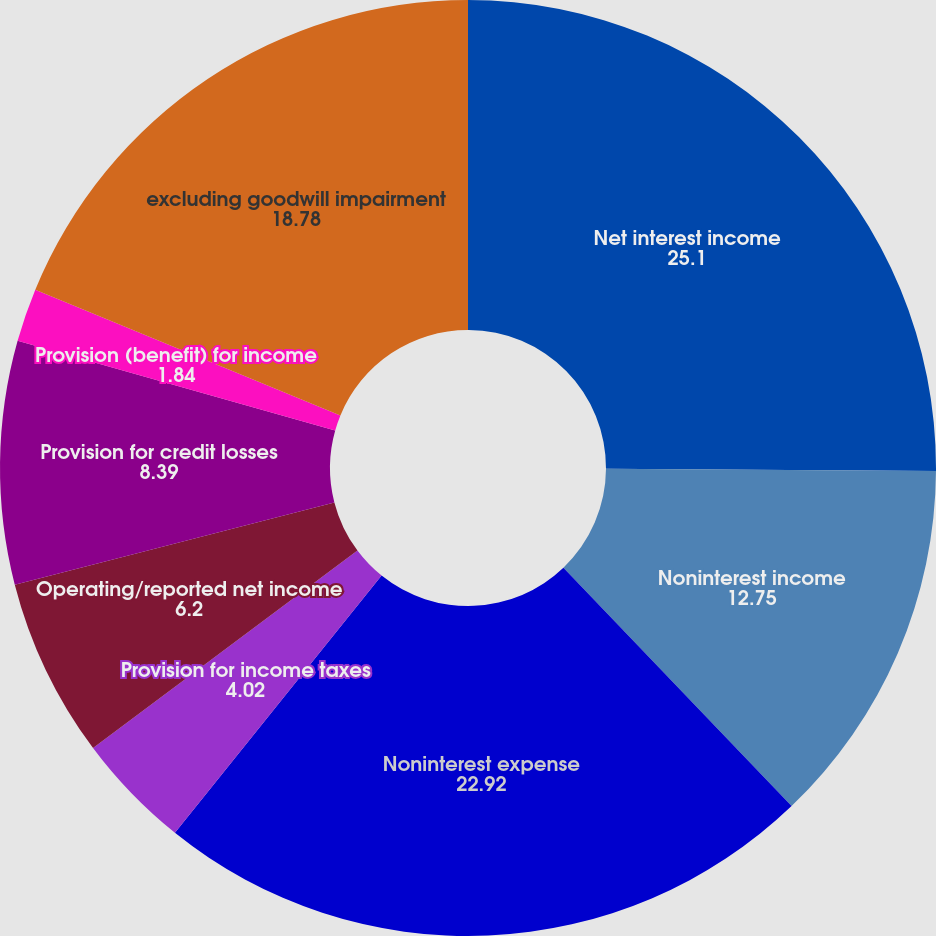<chart> <loc_0><loc_0><loc_500><loc_500><pie_chart><fcel>Net interest income<fcel>Noninterest income<fcel>Noninterest expense<fcel>Provision for income taxes<fcel>Operating/reported net income<fcel>Provision for credit losses<fcel>Provision (benefit) for income<fcel>excluding goodwill impairment<nl><fcel>25.1%<fcel>12.75%<fcel>22.92%<fcel>4.02%<fcel>6.2%<fcel>8.39%<fcel>1.84%<fcel>18.78%<nl></chart> 